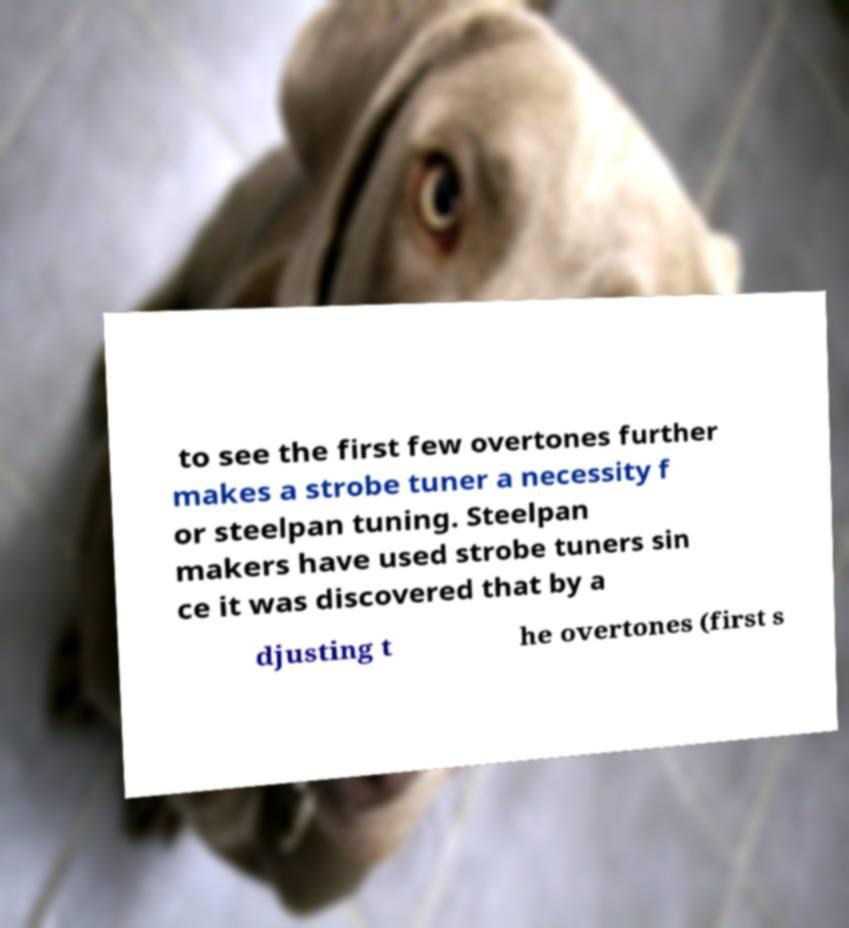Can you accurately transcribe the text from the provided image for me? to see the first few overtones further makes a strobe tuner a necessity f or steelpan tuning. Steelpan makers have used strobe tuners sin ce it was discovered that by a djusting t he overtones (first s 